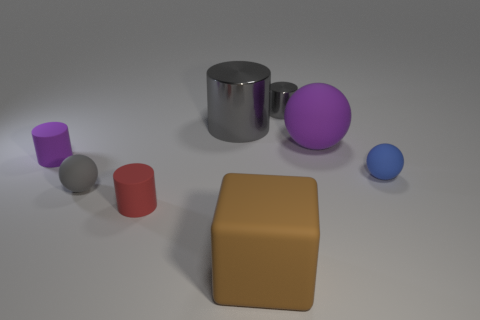Do the large cylinder and the small metallic cylinder have the same color?
Ensure brevity in your answer.  Yes. What material is the big object left of the large brown matte block?
Keep it short and to the point. Metal. Is the number of large things less than the number of gray metallic blocks?
Offer a terse response. No. There is a matte object that is behind the small blue matte ball and right of the small red matte cylinder; what is its size?
Keep it short and to the point. Large. There is a blue sphere that is right of the large thing right of the small gray thing on the right side of the large matte block; what size is it?
Offer a very short reply. Small. What number of other things are the same color as the big metallic object?
Your answer should be very brief. 2. Is the color of the metal cylinder right of the large gray shiny object the same as the large metallic thing?
Provide a succinct answer. Yes. What number of objects are tiny blue cylinders or balls?
Ensure brevity in your answer.  3. There is a large matte thing left of the small metallic cylinder; what color is it?
Provide a short and direct response. Brown. Is the number of small purple objects that are to the right of the tiny blue rubber thing less than the number of red metallic cylinders?
Offer a terse response. No. 